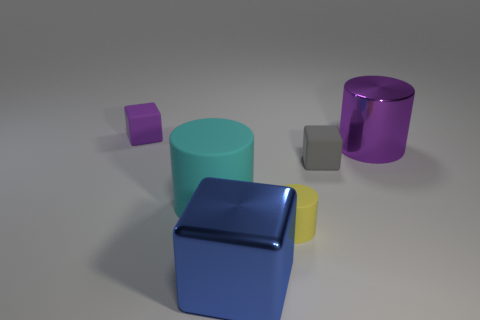The purple object right of the matte cylinder that is on the left side of the large metallic thing in front of the gray matte block is made of what material?
Keep it short and to the point. Metal. Do the large matte cylinder and the cube that is to the right of the big blue metallic object have the same color?
Offer a very short reply. No. What number of objects are either blocks that are in front of the small purple rubber object or large metal objects that are in front of the gray block?
Ensure brevity in your answer.  2. What shape is the large metallic object that is behind the tiny block that is right of the small matte cylinder?
Provide a short and direct response. Cylinder. Is there a cyan cube made of the same material as the big purple thing?
Provide a short and direct response. No. What color is the other matte object that is the same shape as the gray object?
Ensure brevity in your answer.  Purple. Are there fewer large cyan matte things that are in front of the tiny gray matte thing than blue blocks right of the tiny rubber cylinder?
Provide a short and direct response. No. What number of other things are the same shape as the small yellow object?
Provide a short and direct response. 2. Are there fewer yellow cylinders on the left side of the yellow matte cylinder than large yellow metallic cylinders?
Offer a terse response. No. What is the block on the left side of the cyan matte thing made of?
Your response must be concise. Rubber. 